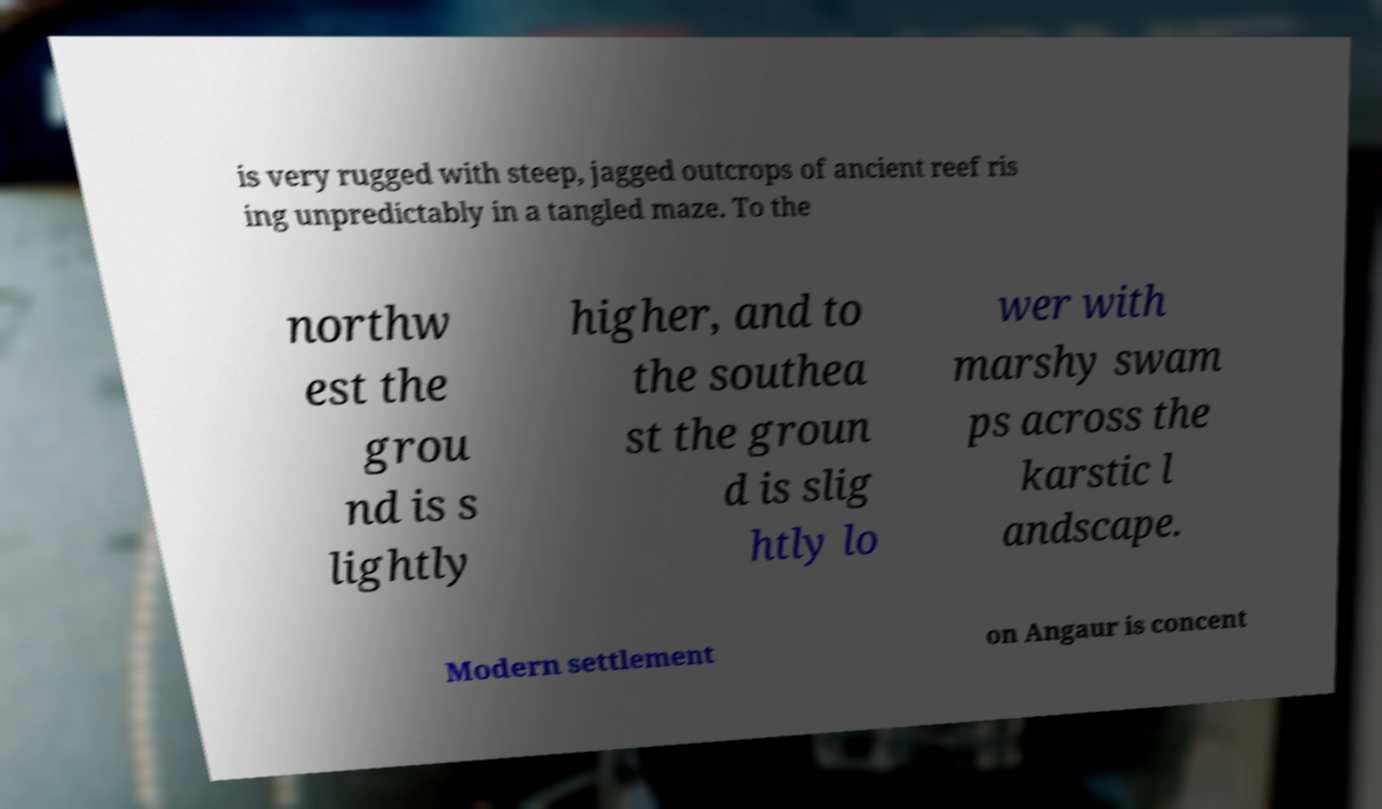Can you accurately transcribe the text from the provided image for me? is very rugged with steep, jagged outcrops of ancient reef ris ing unpredictably in a tangled maze. To the northw est the grou nd is s lightly higher, and to the southea st the groun d is slig htly lo wer with marshy swam ps across the karstic l andscape. Modern settlement on Angaur is concent 